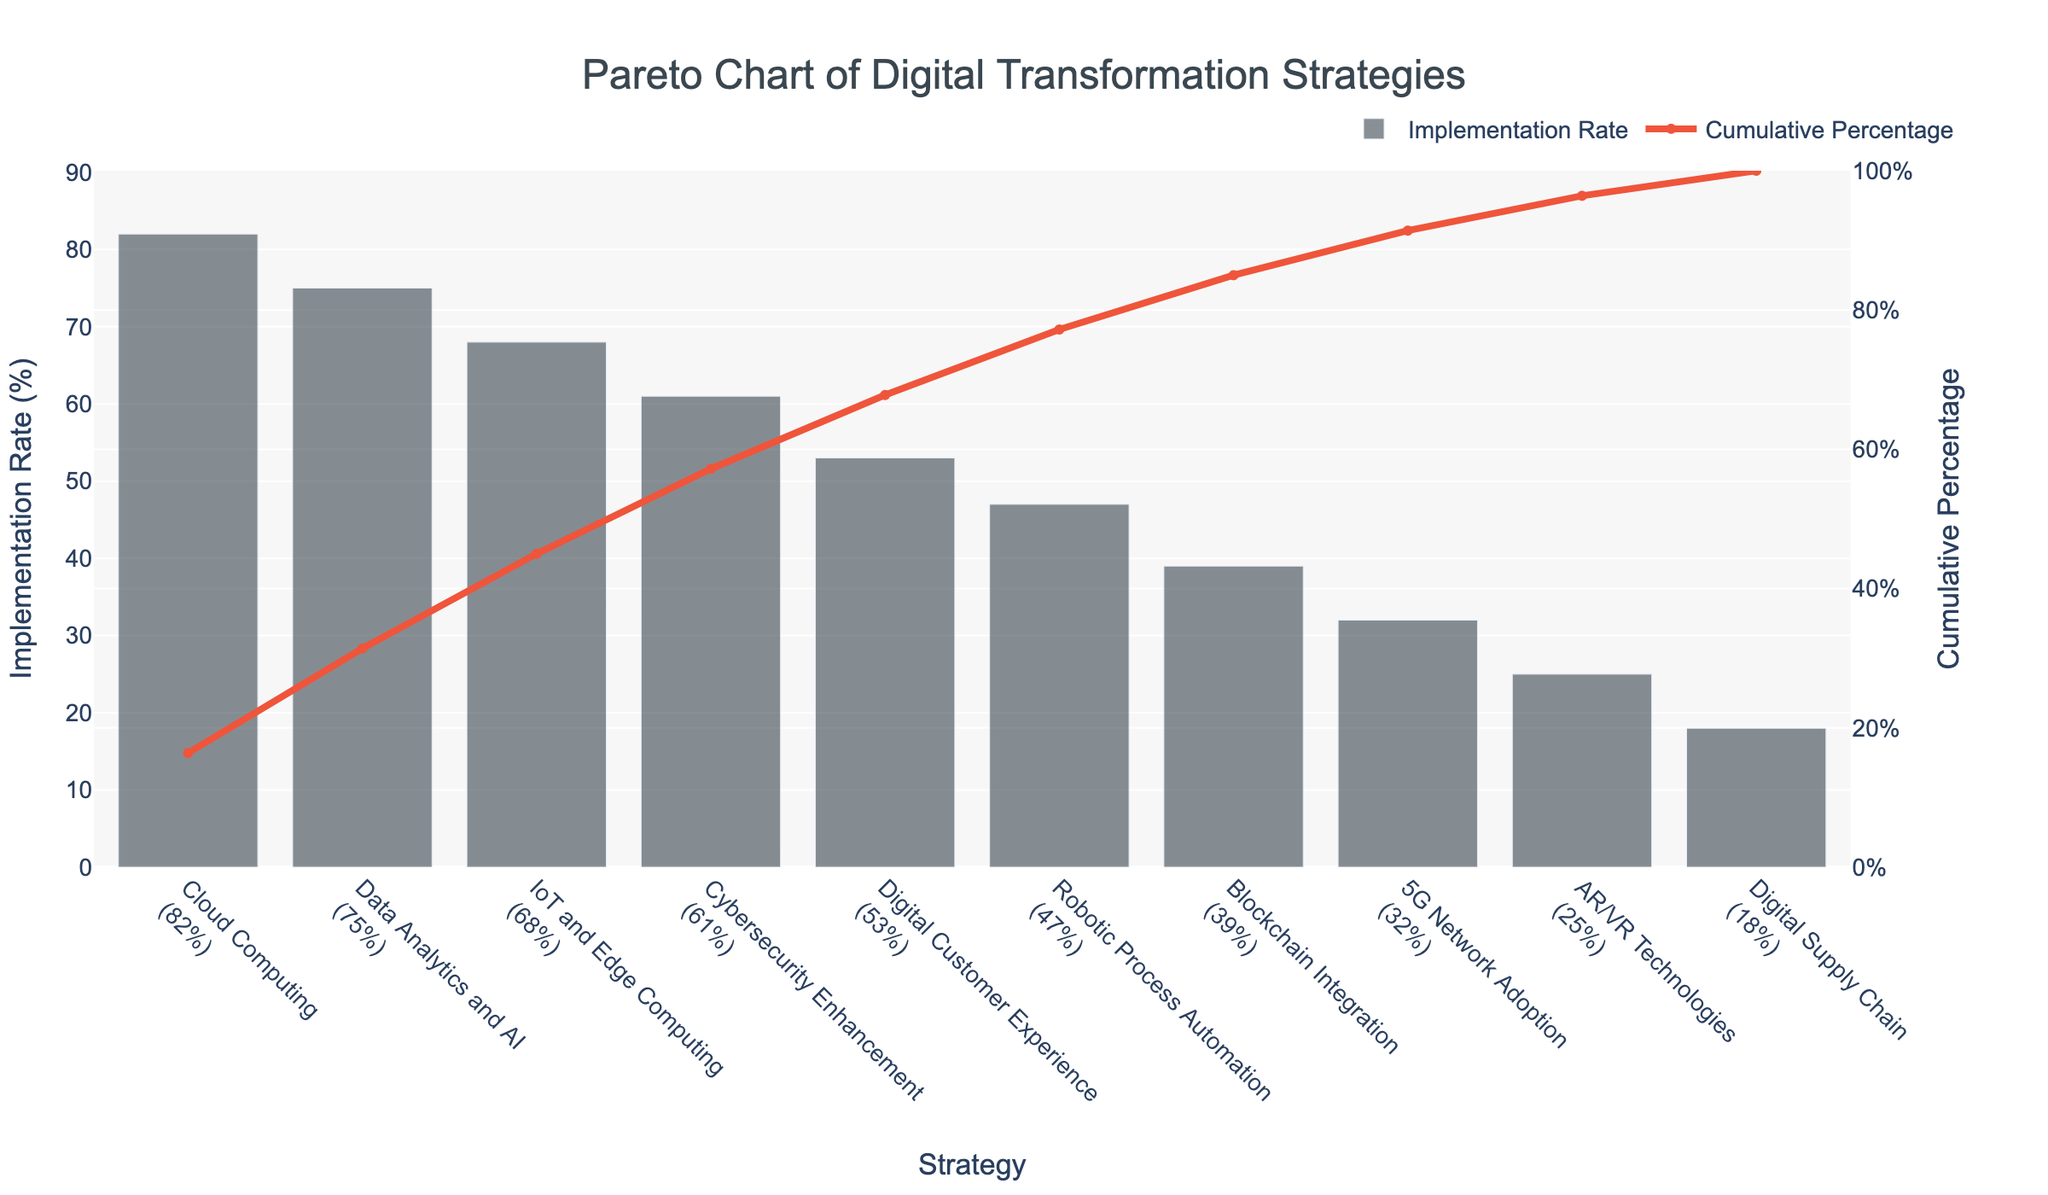what is the most popular digital transformation strategy according to the chart? The most popular digital transformation strategy is identified by the one with the highest implementation rate according to the bar chart. The tallest bar corresponds to 'Cloud Computing' with an implementation rate of 82%.
Answer: Cloud Computing what is the cumulative percentage for the top two strategies? To find the cumulative percentage for the top two strategies, sum their implementation rates and compute the cumulative percentage. For 'Cloud Computing' (82%) and 'Data Analytics and AI' (75%), their sum is 157%. The cumulative percentage at this point is given as 82% (for the first) plus (75/300)*100% = 25%, totaling 82% + 25% ≈ 107%. However, the cumulative percentage directly from the chart for the second bar is approximately 52.3%.
Answer: 52.3% which strategies constitute at least 80% of the cumulative implementation rate? Identify the strategies contributing to at least 80% of the total cumulative implementation rate by summing their individual implementation rates and checking the cumulative percentage. 'Cloud Computing' (82%), 'Data Analytics and AI' (75%), and 'IoT and Edge Computing' (68%) sum up to 225%. From the chart, this about covers 80% of cumulative percentage.
Answer: Cloud Computing, Data Analytics and AI, IoT and Edge Computing what is the implementation rate for 'Cybersecurity Enhancement'? The implementation rate for 'Cybersecurity Enhancement' can be directly read from the height of the bar corresponding to this strategy.
Answer: 61% what strategies have an implementation rate less than 40%? Identify the strategies whose bars are less than 40% implementation rate. From the chart, these strategies are 'Blockchain Integration' (39%), '5G Network Adoption' (32%), 'AR/VR Technologies' (25%), and 'Digital Supply Chain' (18%).
Answer: Blockchain Integration, 5G Network Adoption, AR/VR Technologies, Digital Supply Chain what is the difference in implementation rate between 'Data Analytics and AI' and 'Robotic Process Automation'? Subtract the implementation rate of 'Robotic Process Automation' from 'Data Analytics and AI'. According to the chart, the implementation rates are 75% and 47%, respectively. The difference is 75% - 47% = 28%.
Answer: 28% what color is used for the bars in the chart? The color used for the bars in the chart is specified in a reddish hue. Without using coding terms, it's a shade of grey, likely dark grey.
Answer: Dark grey how does the cumulative percentage line trend when moving from left to right? Observe the line to see its overall trend as it progresses through the strategies. It starts at 0% for Cloud Computing and trends upwards to 100% by the last strategy. This means the cumulative percentage line consistently increases from left to right, reflecting the accumulating total implementation rate.
Answer: It consistently increases what's the highest cumulative percentage shown in the chart? The highest cumulative percentage in a cumulative chart always reaches 100% at the end of the dataset. From the chart, this value is confirmed by the line reaching the top of the y-axis on the right-hand side.
Answer: 100% which strategy follows 'Digital Customer Experience' in terms of implementation rate? Identify the strategy with the next lower bar following 'Digital Customer Experience'. In the chart, the next strategy after 'Digital Customer Experience' with a decrease in implementation rate is 'Robotic Process Automation'.
Answer: Robotic Process Automation 